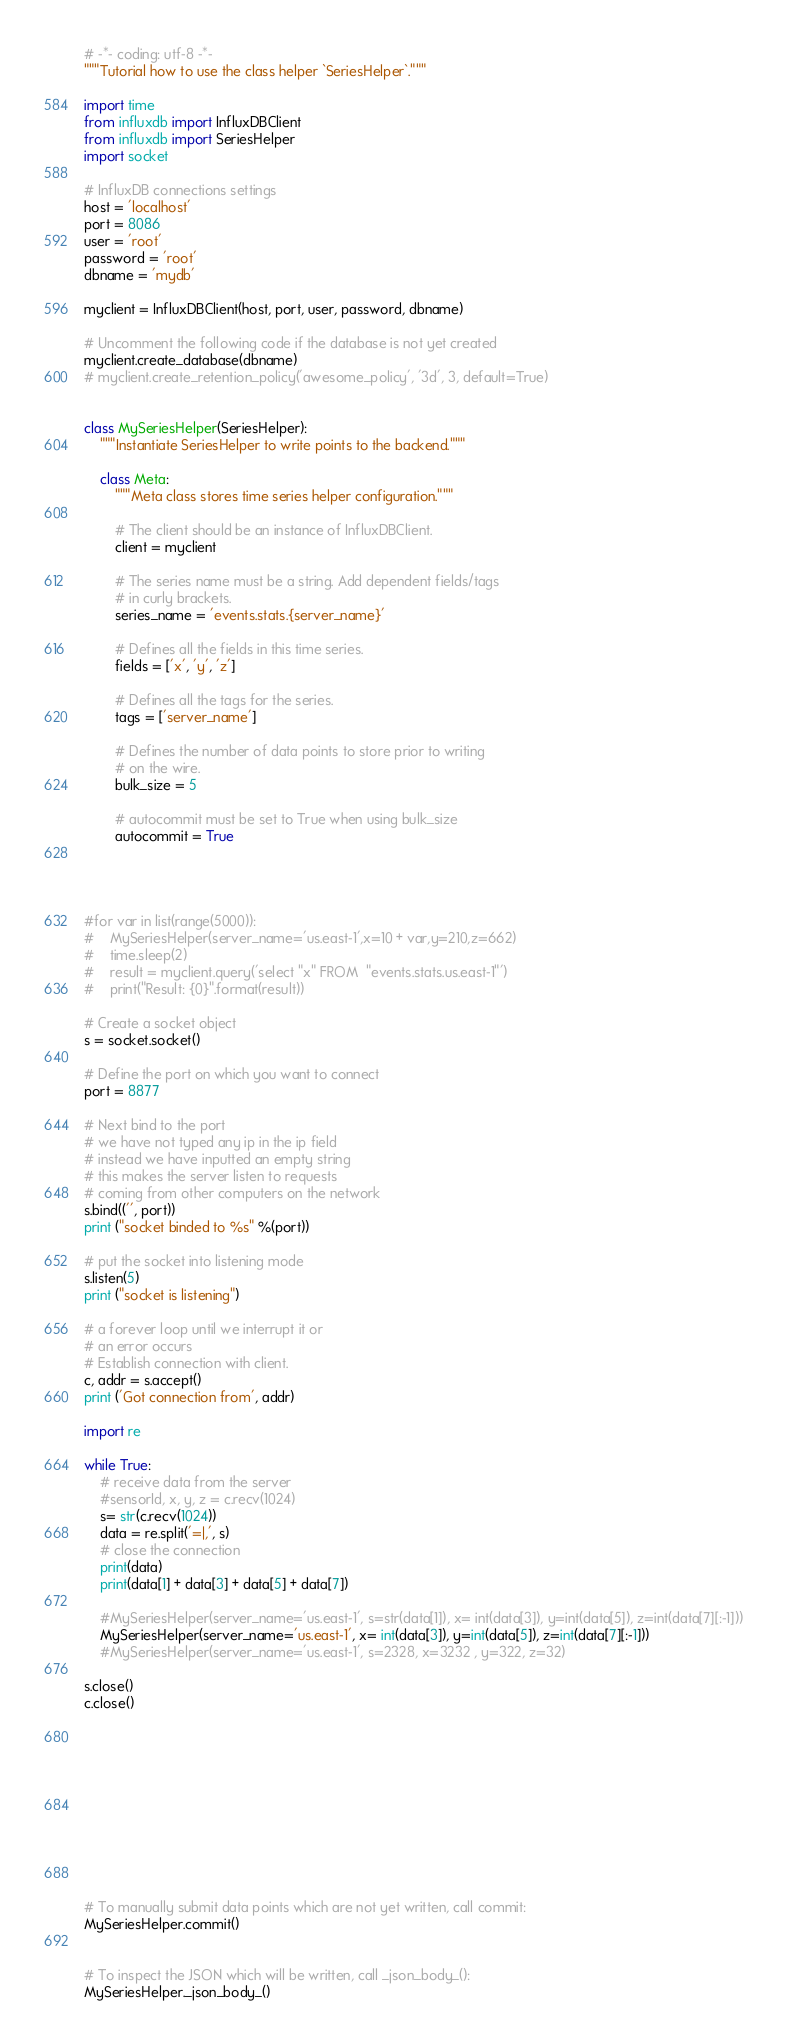<code> <loc_0><loc_0><loc_500><loc_500><_Python_># -*- coding: utf-8 -*-
"""Tutorial how to use the class helper `SeriesHelper`."""

import time
from influxdb import InfluxDBClient
from influxdb import SeriesHelper
import socket

# InfluxDB connections settings
host = 'localhost'
port = 8086
user = 'root'
password = 'root'
dbname = 'mydb'

myclient = InfluxDBClient(host, port, user, password, dbname)

# Uncomment the following code if the database is not yet created
myclient.create_database(dbname)
# myclient.create_retention_policy('awesome_policy', '3d', 3, default=True)


class MySeriesHelper(SeriesHelper):
    """Instantiate SeriesHelper to write points to the backend."""

    class Meta:
        """Meta class stores time series helper configuration."""

        # The client should be an instance of InfluxDBClient.
        client = myclient

        # The series name must be a string. Add dependent fields/tags
        # in curly brackets.
        series_name = 'events.stats.{server_name}'

        # Defines all the fields in this time series.
        fields = ['x', 'y', 'z']

        # Defines all the tags for the series.
        tags = ['server_name']

        # Defines the number of data points to store prior to writing
        # on the wire.
        bulk_size = 5

        # autocommit must be set to True when using bulk_size
        autocommit = True




#for var in list(range(5000)):
#    MySeriesHelper(server_name='us.east-1',x=10 + var,y=210,z=662)
#    time.sleep(2) 
#    result = myclient.query('select "x" FROM  "events.stats.us.east-1"')
#    print("Result: {0}".format(result))

# Create a socket object
s = socket.socket()

# Define the port on which you want to connect
port = 8877

# Next bind to the port
# we have not typed any ip in the ip field
# instead we have inputted an empty string
# this makes the server listen to requests
# coming from other computers on the network
s.bind(('', port))
print ("socket binded to %s" %(port))

# put the socket into listening mode
s.listen(5)
print ("socket is listening")

# a forever loop until we interrupt it or
# an error occurs
# Establish connection with client.
c, addr = s.accept()
print ('Got connection from', addr)

import re

while True:
    # receive data from the server
    #sensorId, x, y, z = c.recv(1024)
    s= str(c.recv(1024))
    data = re.split('=|,', s)
    # close the connection
    print(data)
    print(data[1] + data[3] + data[5] + data[7])

    #MySeriesHelper(server_name='us.east-1', s=str(data[1]), x= int(data[3]), y=int(data[5]), z=int(data[7][:-1]))
    MySeriesHelper(server_name='us.east-1', x= int(data[3]), y=int(data[5]), z=int(data[7][:-1]))
    #MySeriesHelper(server_name='us.east-1', s=2328, x=3232 , y=322, z=32)
    
s.close()
c.close()











# To manually submit data points which are not yet written, call commit:
MySeriesHelper.commit()


# To inspect the JSON which will be written, call _json_body_():
MySeriesHelper._json_body_()

</code> 